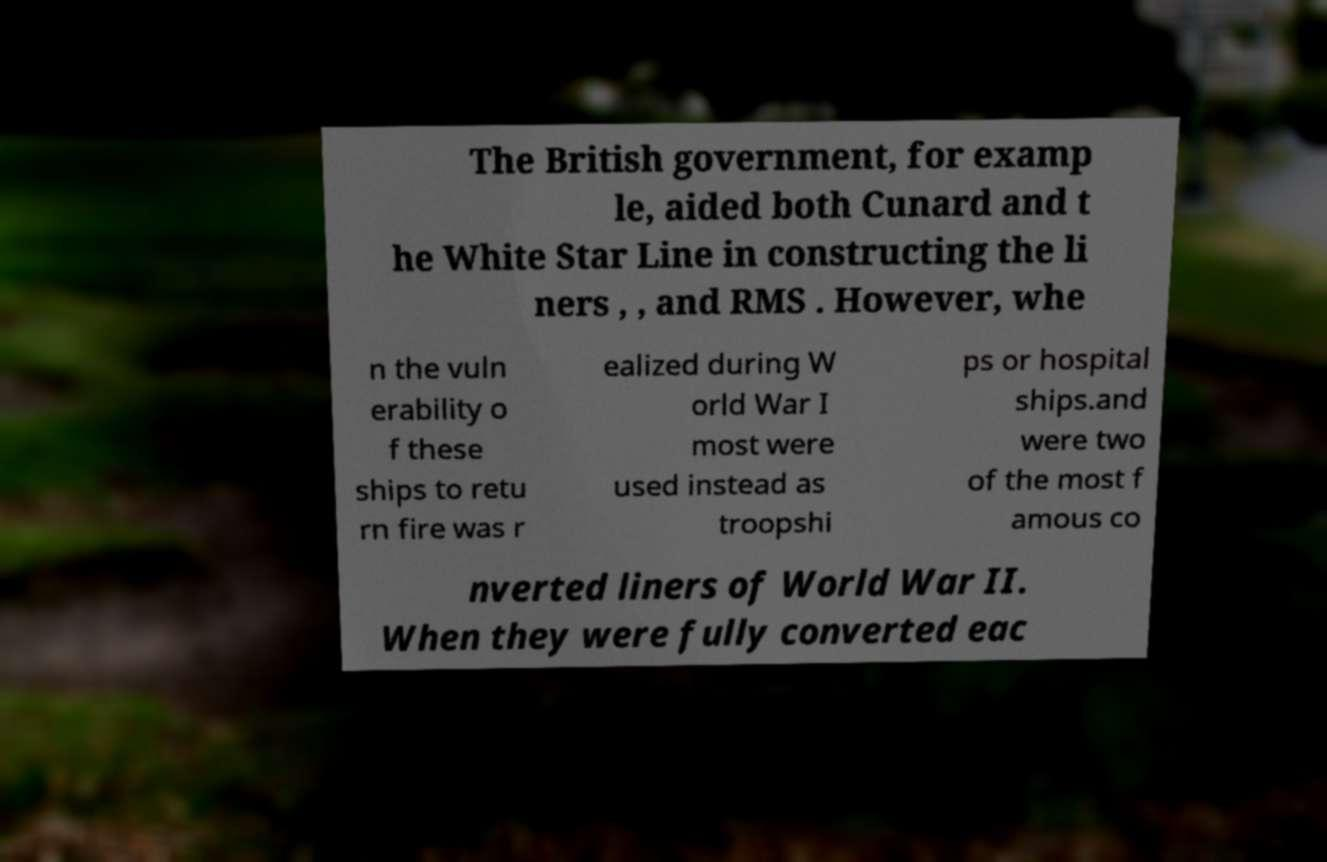There's text embedded in this image that I need extracted. Can you transcribe it verbatim? The British government, for examp le, aided both Cunard and t he White Star Line in constructing the li ners , , and RMS . However, whe n the vuln erability o f these ships to retu rn fire was r ealized during W orld War I most were used instead as troopshi ps or hospital ships.and were two of the most f amous co nverted liners of World War II. When they were fully converted eac 